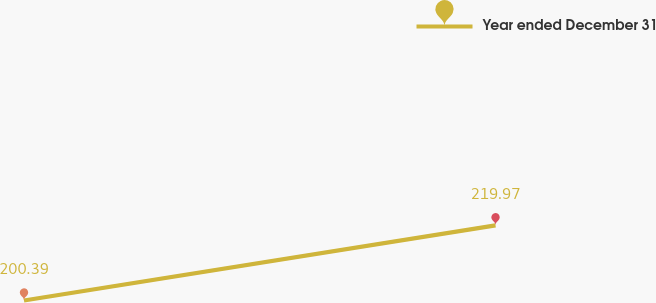Convert chart. <chart><loc_0><loc_0><loc_500><loc_500><line_chart><ecel><fcel>Year ended December 31<nl><fcel>1846.64<fcel>200.39<nl><fcel>1949.55<fcel>219.97<nl><fcel>2126<fcel>129.04<nl></chart> 